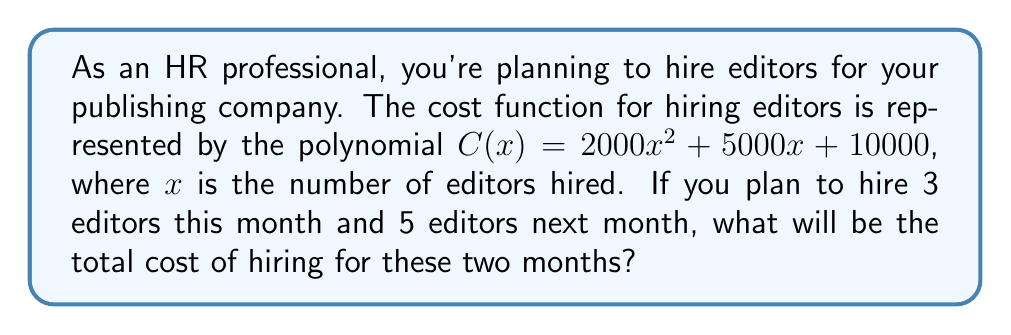Show me your answer to this math problem. To solve this problem, we need to use the given cost function and calculate the cost for each month separately, then add them together. Let's break it down step-by-step:

1. Cost function: $C(x) = 2000x^2 + 5000x + 10000$

2. For the first month (3 editors):
   $C(3) = 2000(3)^2 + 5000(3) + 10000$
   $= 2000(9) + 15000 + 10000$
   $= 18000 + 15000 + 10000$
   $= 43000$

3. For the second month (5 editors):
   $C(5) = 2000(5)^2 + 5000(5) + 10000$
   $= 2000(25) + 25000 + 10000$
   $= 50000 + 25000 + 10000$
   $= 85000$

4. Total cost for both months:
   Total Cost = Cost for first month + Cost for second month
   $= C(3) + C(5)$
   $= 43000 + 85000$
   $= 128000$

Therefore, the total cost of hiring 3 editors in the first month and 5 editors in the second month is $128,000.
Answer: $128,000 